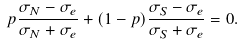Convert formula to latex. <formula><loc_0><loc_0><loc_500><loc_500>p \frac { \sigma _ { N } - \sigma _ { e } } { \sigma _ { N } + \sigma _ { e } } + ( 1 - p ) \frac { \sigma _ { S } - \sigma _ { e } } { \sigma _ { S } + \sigma _ { e } } = 0 .</formula> 